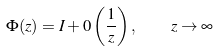<formula> <loc_0><loc_0><loc_500><loc_500>\Phi ( z ) = I + 0 \left ( \frac { 1 } { z } \right ) , \quad z \to \infty</formula> 